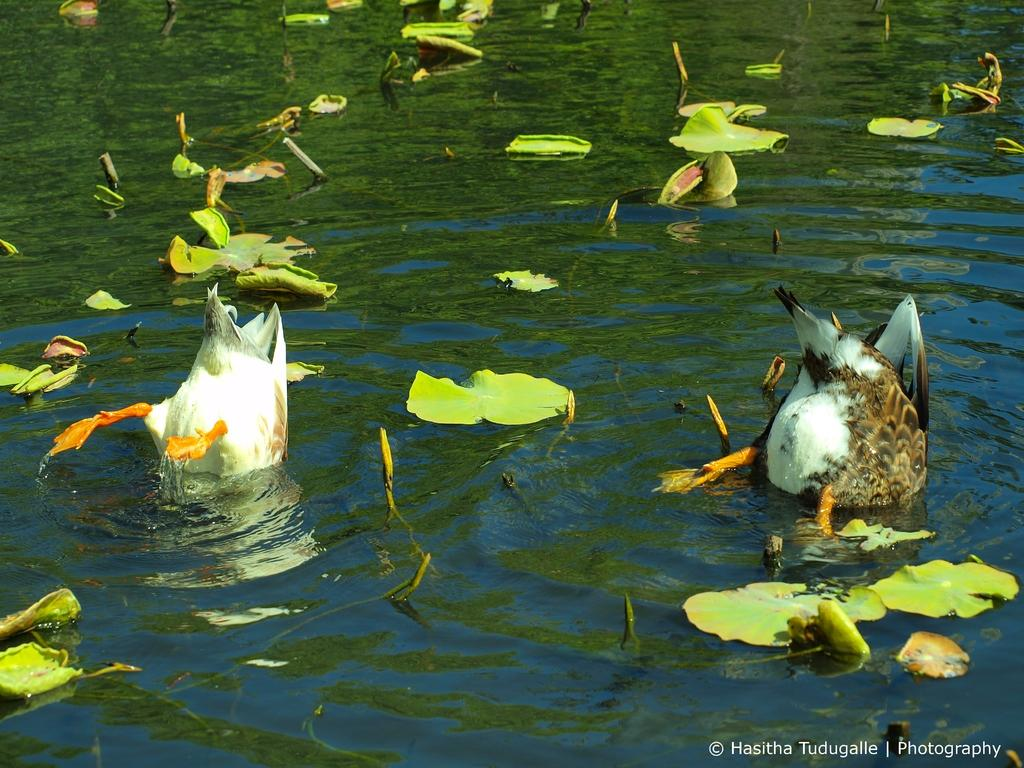How many birds can be seen in the image? There are two birds in the image. What type of plants are present in the water? There are lotus plants in the water. Is there any text visible in the image? Yes, there is a text in the image. What type of location might the image be taken at? The image is likely taken at a lake. What time of day is the image likely taken? The image is likely taken during the day. What type of group or class is being taught by the donkey in the image? There is no donkey present in the image, so it is not possible to answer that question. 